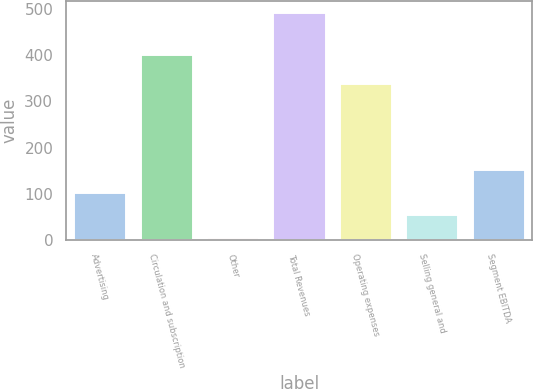Convert chart to OTSL. <chart><loc_0><loc_0><loc_500><loc_500><bar_chart><fcel>Advertising<fcel>Circulation and subscription<fcel>Other<fcel>Total Revenues<fcel>Operating expenses<fcel>Selling general and<fcel>Segment EBITDA<nl><fcel>103.6<fcel>402<fcel>6<fcel>494<fcel>341<fcel>54.8<fcel>152.4<nl></chart> 